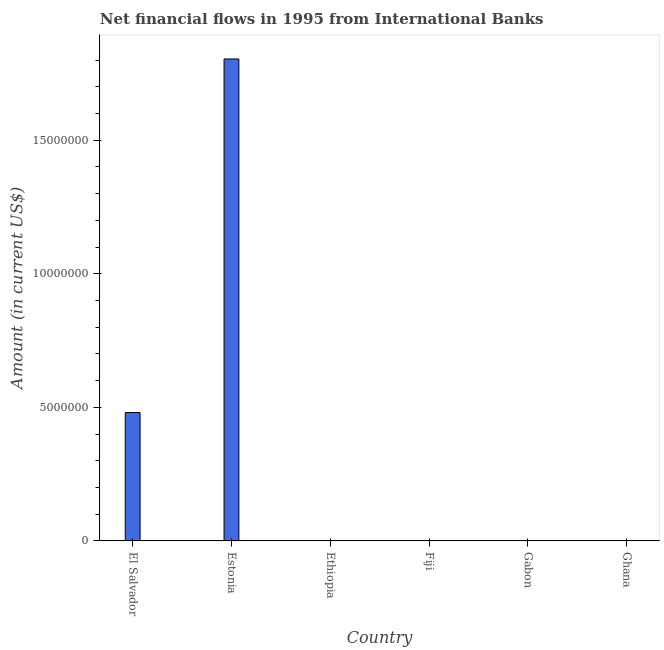What is the title of the graph?
Your answer should be compact. Net financial flows in 1995 from International Banks. What is the label or title of the X-axis?
Provide a succinct answer. Country. What is the label or title of the Y-axis?
Provide a succinct answer. Amount (in current US$). What is the net financial flows from ibrd in Gabon?
Your response must be concise. 0. Across all countries, what is the maximum net financial flows from ibrd?
Provide a short and direct response. 1.80e+07. Across all countries, what is the minimum net financial flows from ibrd?
Provide a succinct answer. 0. In which country was the net financial flows from ibrd maximum?
Offer a terse response. Estonia. What is the sum of the net financial flows from ibrd?
Offer a very short reply. 2.28e+07. What is the difference between the net financial flows from ibrd in El Salvador and Estonia?
Provide a succinct answer. -1.32e+07. What is the average net financial flows from ibrd per country?
Offer a very short reply. 3.81e+06. What is the median net financial flows from ibrd?
Provide a short and direct response. 0. In how many countries, is the net financial flows from ibrd greater than 13000000 US$?
Offer a very short reply. 1. Is the net financial flows from ibrd in El Salvador less than that in Estonia?
Your answer should be very brief. Yes. What is the difference between the highest and the lowest net financial flows from ibrd?
Give a very brief answer. 1.80e+07. In how many countries, is the net financial flows from ibrd greater than the average net financial flows from ibrd taken over all countries?
Make the answer very short. 2. Are all the bars in the graph horizontal?
Make the answer very short. No. What is the difference between two consecutive major ticks on the Y-axis?
Give a very brief answer. 5.00e+06. What is the Amount (in current US$) of El Salvador?
Provide a succinct answer. 4.81e+06. What is the Amount (in current US$) of Estonia?
Provide a short and direct response. 1.80e+07. What is the difference between the Amount (in current US$) in El Salvador and Estonia?
Give a very brief answer. -1.32e+07. What is the ratio of the Amount (in current US$) in El Salvador to that in Estonia?
Ensure brevity in your answer.  0.27. 